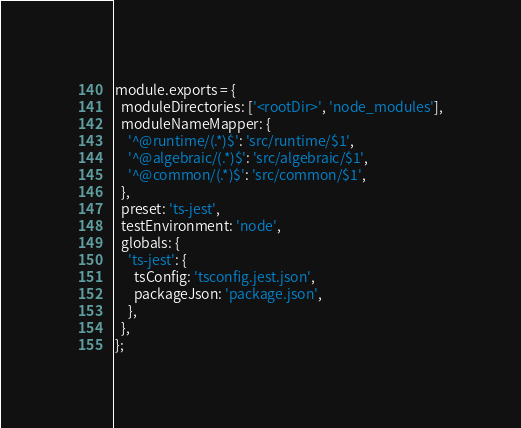<code> <loc_0><loc_0><loc_500><loc_500><_JavaScript_>module.exports = {
  moduleDirectories: ['<rootDir>', 'node_modules'],
  moduleNameMapper: {
    '^@runtime/(.*)$': 'src/runtime/$1',
    '^@algebraic/(.*)$': 'src/algebraic/$1',
    '^@common/(.*)$': 'src/common/$1',
  },
  preset: 'ts-jest',
  testEnvironment: 'node',
  globals: {
    'ts-jest': {
      tsConfig: 'tsconfig.jest.json',
      packageJson: 'package.json',
    },
  },
};
</code> 